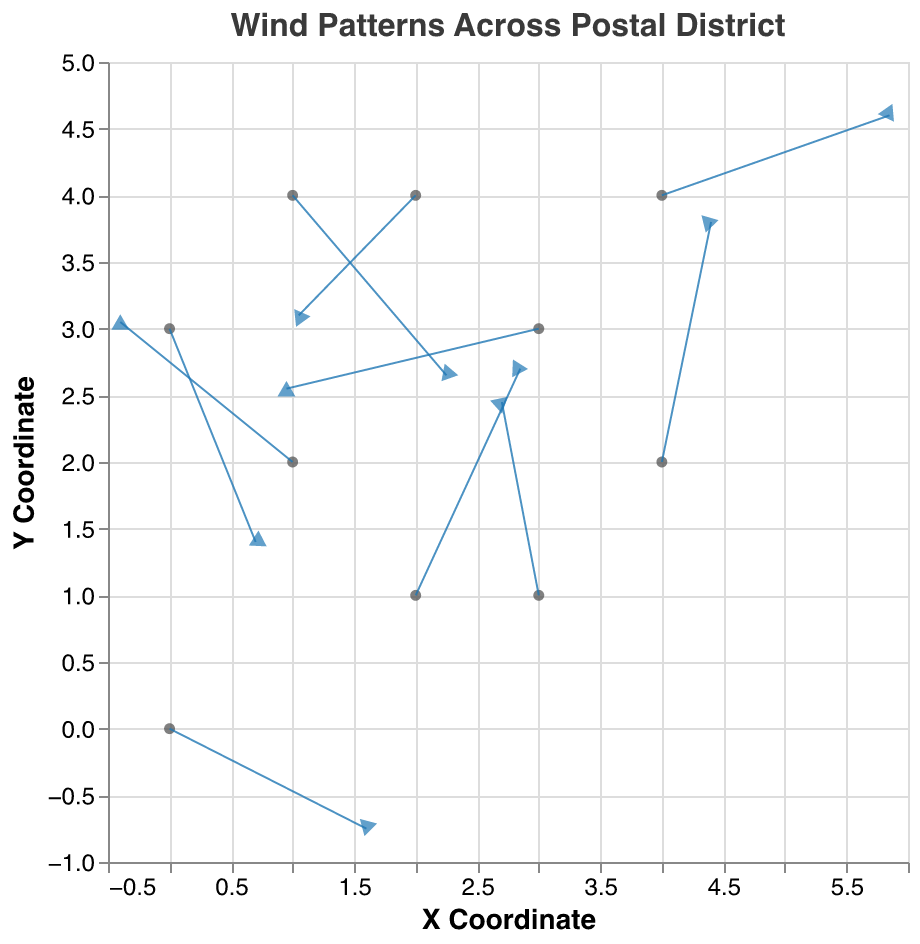What's the direction of the wind vector at Main Post Office? The wind vector at Main Post Office points in the positive x direction and negative y direction. This can be observed through the values of u (3.2) and v (-1.5).
Answer: Positive x, Negative y Which location experiences the highest wind speed? The wind speed is found using sqrt(u^2 + v^2). Calculating this for each location, we find Pinecrest Road has the highest wind speed with sqrt(3.7^2 + 1.2^2) = 3.89.
Answer: Pinecrest Road Compare the wind direction at Hillcrest Drive and Oakwood Park. Which one points more to the east? Hillcrest Drive has u = -4.1 (negative, westward) and Oakwood Park has u = -2.8 (negative, westward), but since -2.8 is greater than -4.1, Oakwood Park points more to the east.
Answer: Oakwood Park What is the average x-component (u) of the wind vectors across all locations? Sum all the x-components (u) and divide by the number of locations; (3.2 -2.8 + 1.7 -4.1 + 2.5 + 0.8 -1.9 + 3.7 -0.6 + 1.4) / 10 results in a total of 3.9 / 10 = 0.39.
Answer: 0.39 Which location has the steepest upward wind direction? "Upward" corresponds to the largest positive y-component (v). Comparing v values, Sunnydale Avenue has the highest upward direction with v = 3.6.
Answer: Sunnydale Avenue What is the total number of data points represented in the plot? The plot contains arrows for each location. Counting these, there are 10 data points.
Answer: 10 Determine the net x displacement for all vectors combined. The net x displacement is the sum of all x components (u); (3.2 -2.8 + 1.7 -4.1 + 2.5 + 0.8 -1.9 + 3.7 -0.6 + 1.4) equals 3.9.
Answer: 3.9 